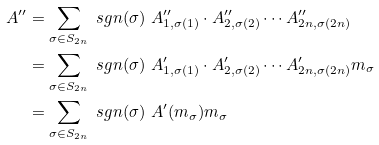<formula> <loc_0><loc_0><loc_500><loc_500>A ^ { \prime \prime } & = \sum _ { \sigma \in S _ { 2 n } } \ s g n ( \sigma ) \ A ^ { \prime \prime } _ { 1 , \sigma ( 1 ) } \cdot A ^ { \prime \prime } _ { 2 , \sigma ( 2 ) } \cdots A ^ { \prime \prime } _ { 2 n , \sigma ( 2 n ) } \\ & = \sum _ { \sigma \in S _ { 2 n } } \ s g n ( \sigma ) \ A ^ { \prime } _ { 1 , \sigma ( 1 ) } \cdot A ^ { \prime } _ { 2 , \sigma ( 2 ) } \cdots A ^ { \prime } _ { 2 n , \sigma ( 2 n ) } m _ { \sigma } \\ & = \sum _ { \sigma \in S _ { 2 n } } \ s g n ( \sigma ) \ A ^ { \prime } ( m _ { \sigma } ) m _ { \sigma }</formula> 